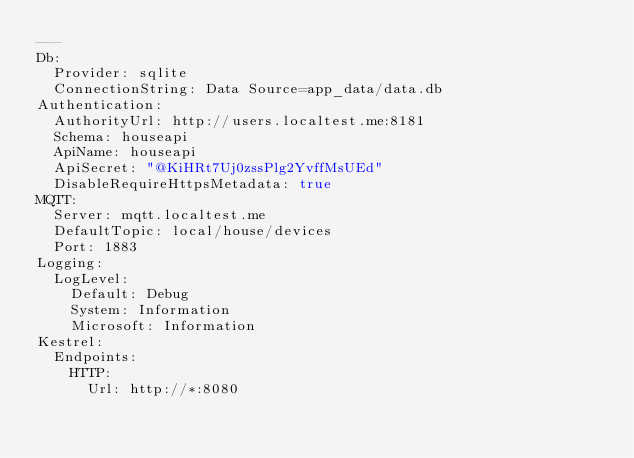Convert code to text. <code><loc_0><loc_0><loc_500><loc_500><_YAML_>---
Db:
  Provider: sqlite
  ConnectionString: Data Source=app_data/data.db
Authentication:
  AuthorityUrl: http://users.localtest.me:8181
  Schema: houseapi
  ApiName: houseapi
  ApiSecret: "@KiHRt7Uj0zssPlg2YvffMsUEd"
  DisableRequireHttpsMetadata: true
MQTT:
  Server: mqtt.localtest.me
  DefaultTopic: local/house/devices
  Port: 1883
Logging:
  LogLevel:
    Default: Debug
    System: Information
    Microsoft: Information
Kestrel:
  Endpoints:
    HTTP:
      Url: http://*:8080
</code> 